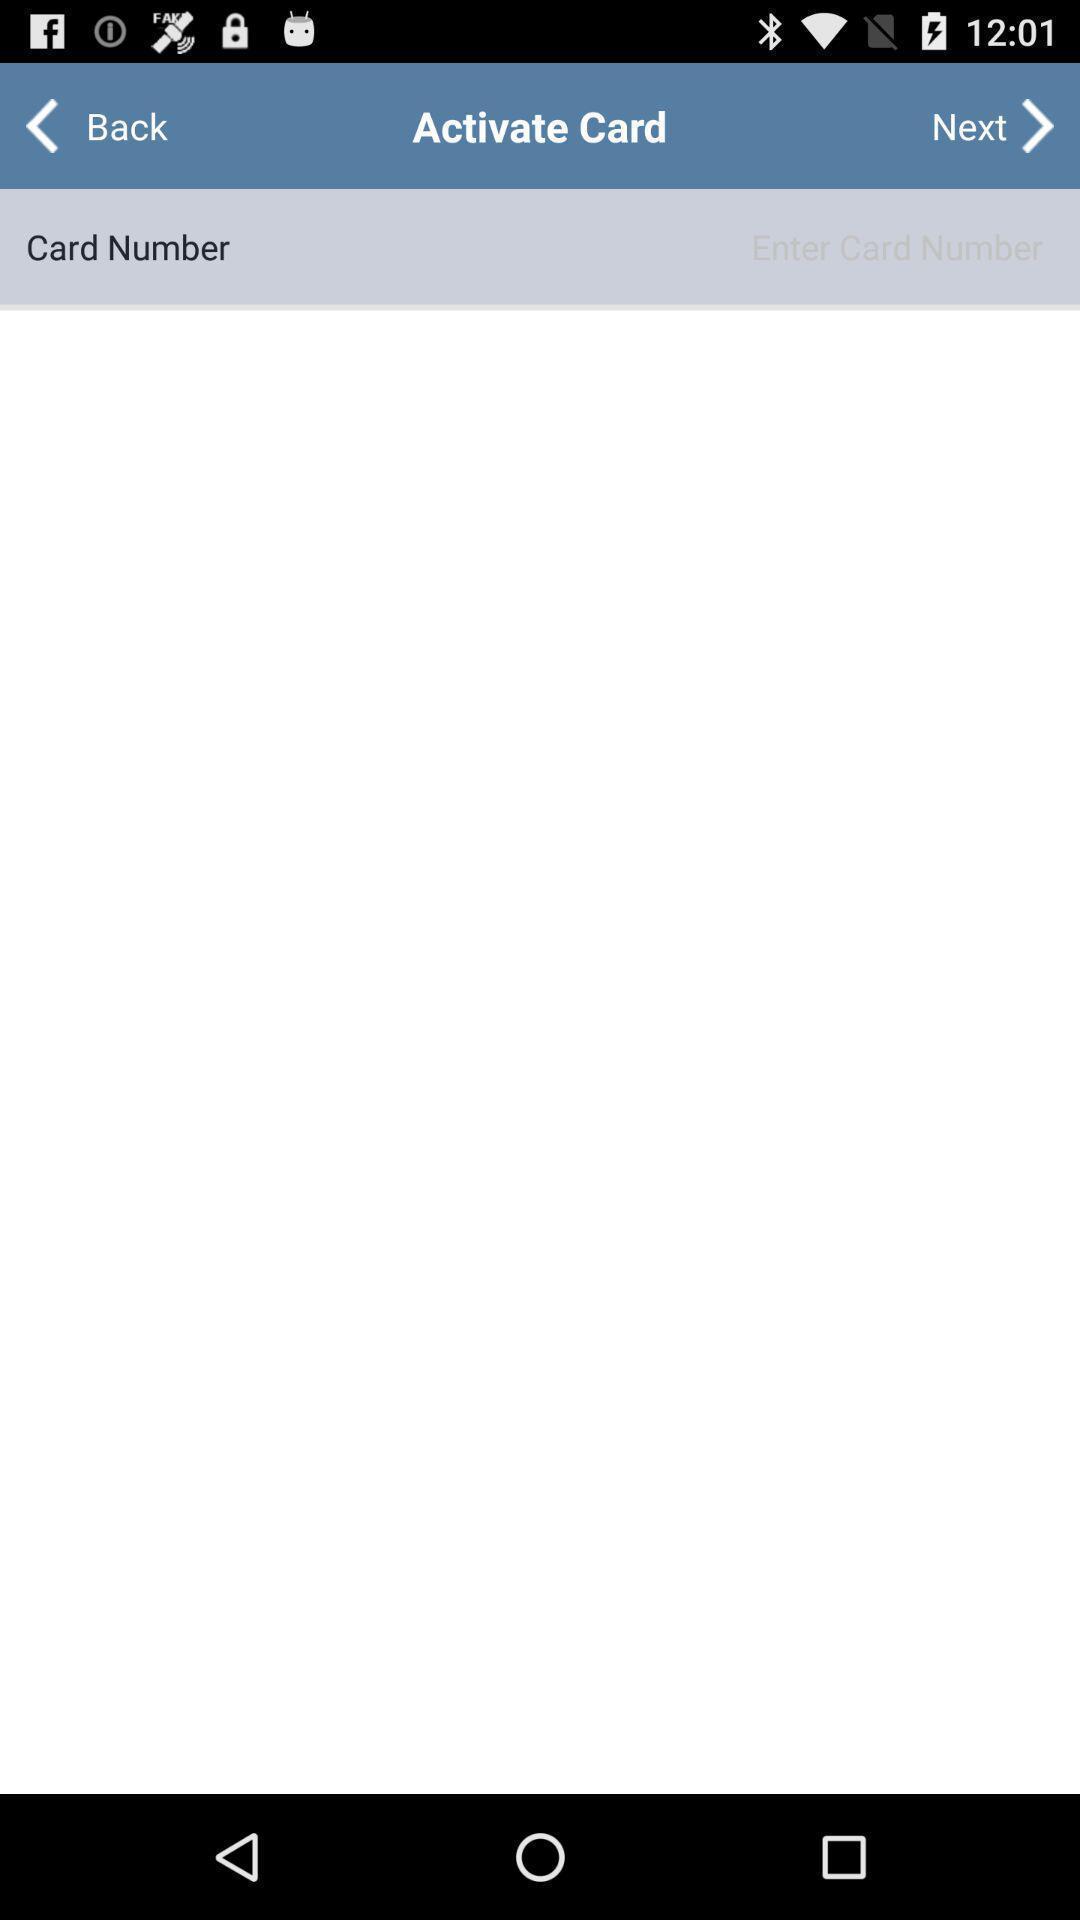Provide a description of this screenshot. Page shows card details of a financial application. 